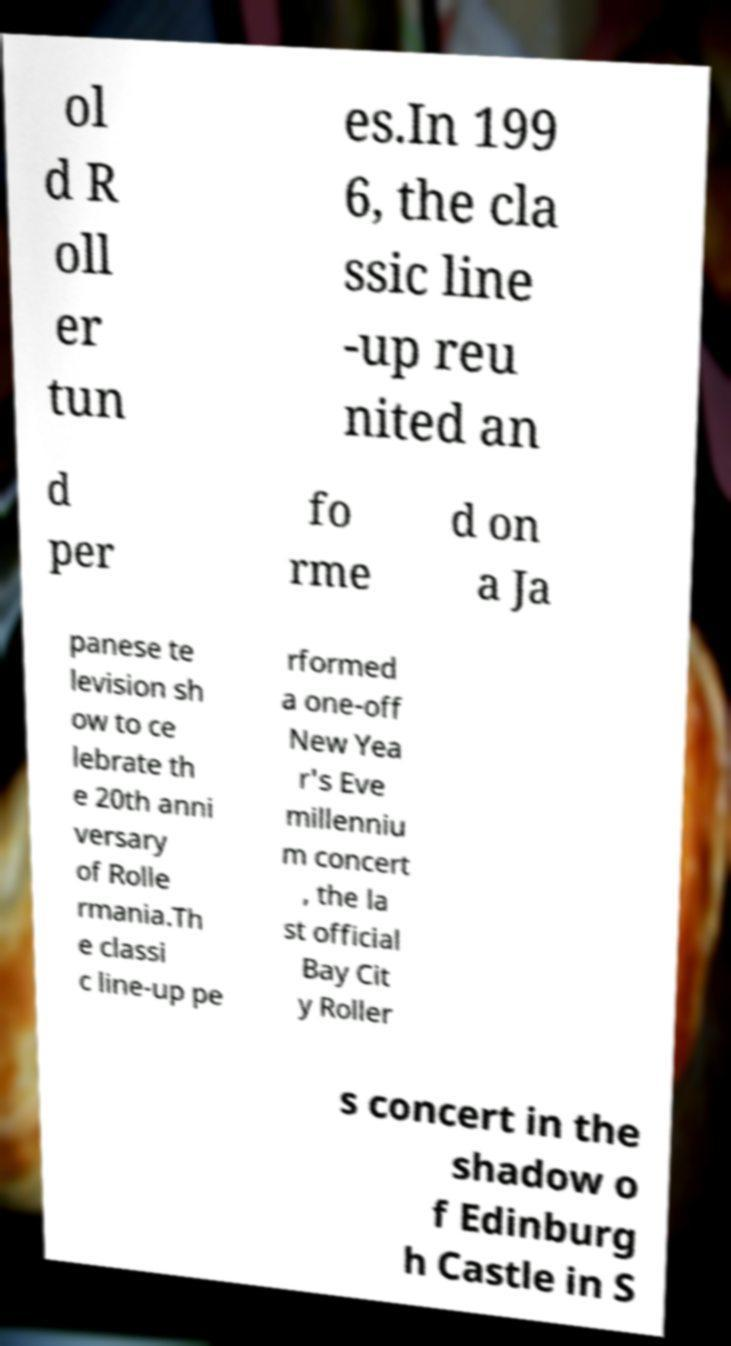Can you read and provide the text displayed in the image?This photo seems to have some interesting text. Can you extract and type it out for me? ol d R oll er tun es.In 199 6, the cla ssic line -up reu nited an d per fo rme d on a Ja panese te levision sh ow to ce lebrate th e 20th anni versary of Rolle rmania.Th e classi c line-up pe rformed a one-off New Yea r's Eve millenniu m concert , the la st official Bay Cit y Roller s concert in the shadow o f Edinburg h Castle in S 